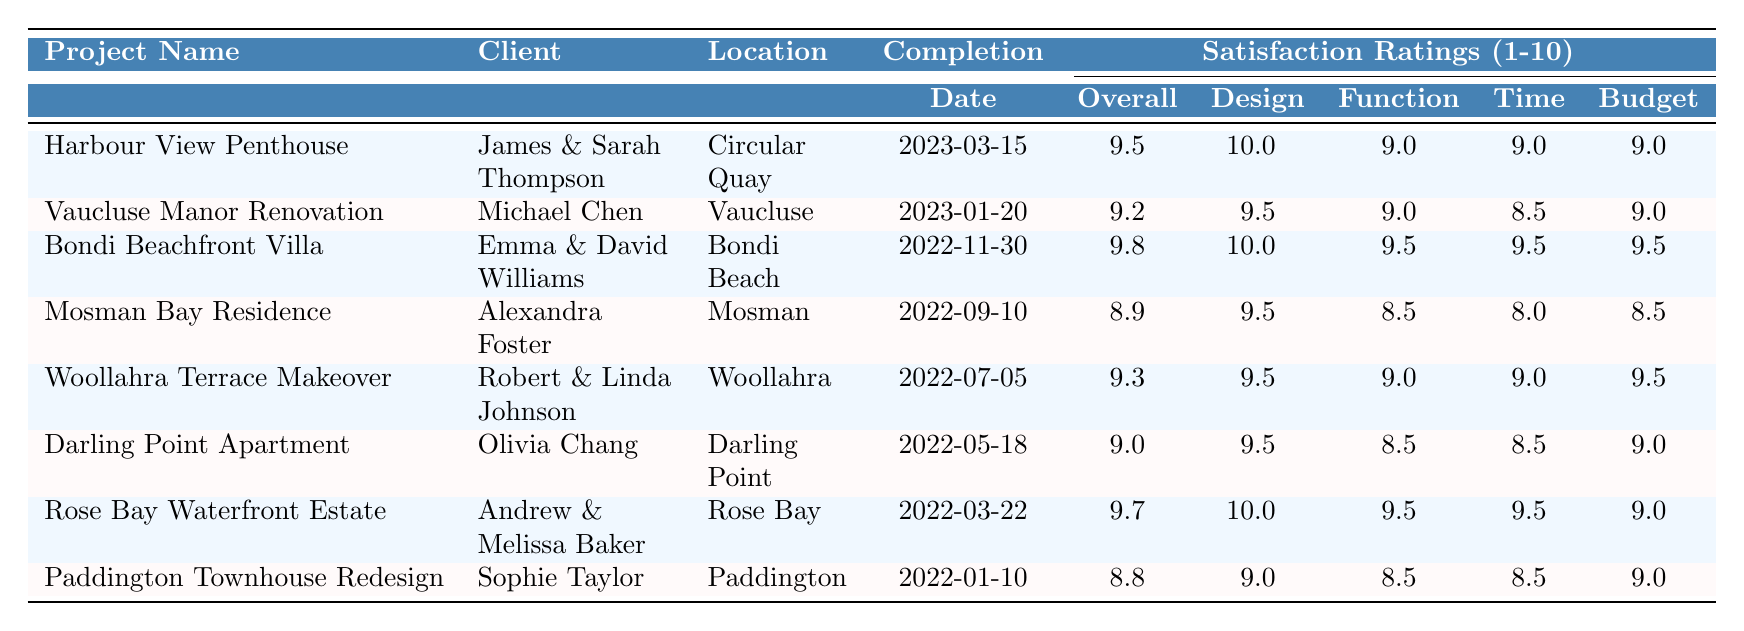What is the overall satisfaction rating for the Harbour View Penthouse? The rating for the Harbour View Penthouse is listed directly in the table under the "Overall Satisfaction" column, which shows a score of 9.5.
Answer: 9.5 Which project had the highest score for Design Aesthetics? The project with the highest score in the "Design Aesthetics" column is the Bondi Beachfront Villa, which received a score of 10.
Answer: Bondi Beachfront Villa What was the overall satisfaction rating for the Mosman Bay Residence? Looking at the table, the overall satisfaction rating for the Mosman Bay Residence is 8.9, as shown in the corresponding column for that project.
Answer: 8.9 What is the average budget adherence rating for all projects? To calculate the average budget adherence, find the sum of the scores in the "Budget Adherence" column: (9 + 9 + 9.5 + 8.5 + 9.5 + 9 + 9 + 9) = 72. The total number of projects is 8; therefore, the average is 72/8 = 9.
Answer: 9 Did all projects score above 8 in Timeliness? Checking the "Timeliness" column for each project, we find that the lowest score is 8 (for the Mosman Bay Residence), which confirms that all projects are above this threshold.
Answer: Yes Which client rated their project the highest in Functionality? In the "Functionality" column, the highest rating of 9.5 appears for the Bondi Beachfront Villa and the Rose Bay Waterfront Estate. The clients for these projects are Emma & David Williams and Andrew & Melissa Baker, respectively.
Answer: Emma & David Williams and Andrew & Melissa Baker How many projects had an overall satisfaction rating below 9? Counting the overall satisfaction ratings below 9, we find the Mosman Bay Residence (8.9) and the Paddington Townhouse Redesign (8.8), resulting in 2 projects.
Answer: 2 What is the difference between the highest and lowest Design Aesthetics ratings? The highest rating in the "Design Aesthetics" column is 10 (Bondi Beachfront Villa and Rose Bay Waterfront Estate) and the lowest is 9 (for the Paddington Townhouse Redesign). Their difference is 10 - 9 = 1.
Answer: 1 Which project had the best adherence to budget? The project with the best adherence to budget scored 9.5 in the "Budget Adherence" column, which applies to the Bondi Beachfront Villa and the Rose Bay Waterfront Estate.
Answer: Bondi Beachfront Villa and Rose Bay Waterfront Estate Which location had clients that provided the lowest overall satisfaction rating? Referring to the locations, the project with the lowest overall satisfaction rating is located in Mosman, where clients rated 8.9 for the Mosman Bay Residence.
Answer: Mosman 